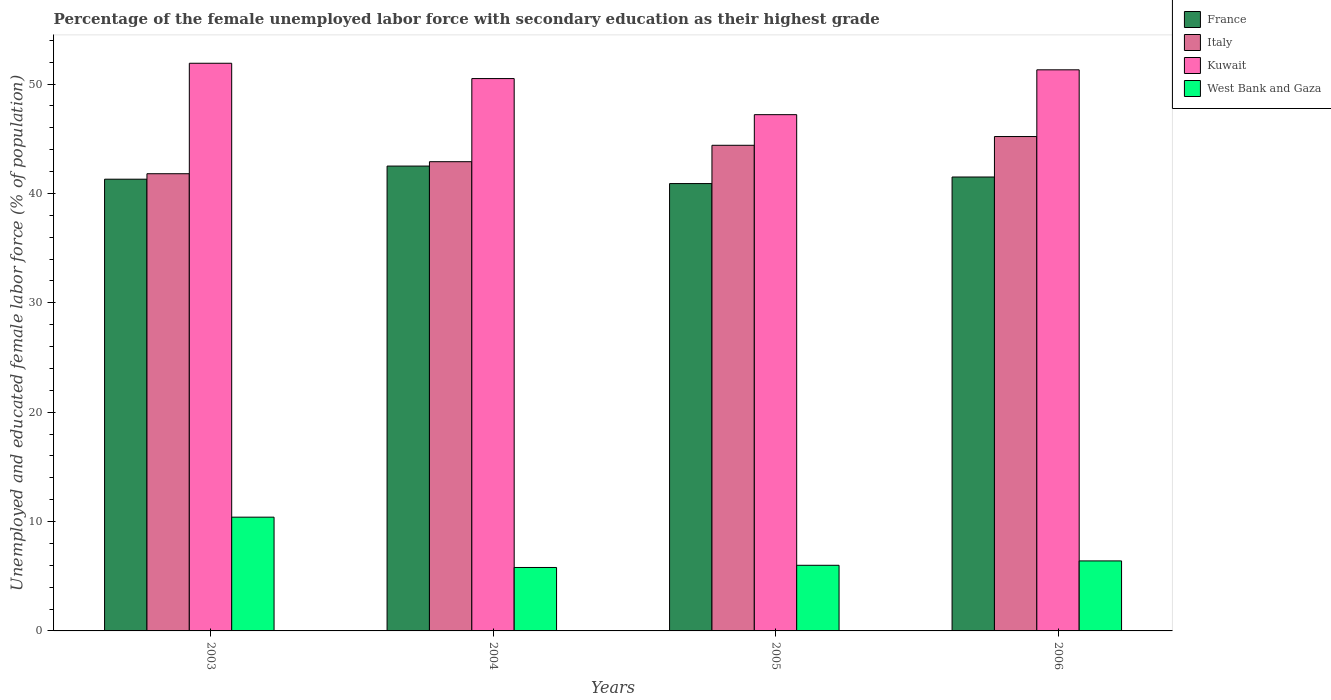Are the number of bars per tick equal to the number of legend labels?
Provide a short and direct response. Yes. Are the number of bars on each tick of the X-axis equal?
Provide a short and direct response. Yes. How many bars are there on the 2nd tick from the right?
Offer a terse response. 4. What is the label of the 3rd group of bars from the left?
Your response must be concise. 2005. In how many cases, is the number of bars for a given year not equal to the number of legend labels?
Keep it short and to the point. 0. What is the percentage of the unemployed female labor force with secondary education in Kuwait in 2004?
Your response must be concise. 50.5. Across all years, what is the maximum percentage of the unemployed female labor force with secondary education in West Bank and Gaza?
Your answer should be very brief. 10.4. Across all years, what is the minimum percentage of the unemployed female labor force with secondary education in Kuwait?
Give a very brief answer. 47.2. In which year was the percentage of the unemployed female labor force with secondary education in France minimum?
Keep it short and to the point. 2005. What is the total percentage of the unemployed female labor force with secondary education in Kuwait in the graph?
Your answer should be compact. 200.9. What is the difference between the percentage of the unemployed female labor force with secondary education in France in 2005 and that in 2006?
Give a very brief answer. -0.6. What is the difference between the percentage of the unemployed female labor force with secondary education in Kuwait in 2003 and the percentage of the unemployed female labor force with secondary education in France in 2006?
Your response must be concise. 10.4. What is the average percentage of the unemployed female labor force with secondary education in Kuwait per year?
Your response must be concise. 50.23. In the year 2003, what is the difference between the percentage of the unemployed female labor force with secondary education in France and percentage of the unemployed female labor force with secondary education in Italy?
Your response must be concise. -0.5. In how many years, is the percentage of the unemployed female labor force with secondary education in France greater than 38 %?
Keep it short and to the point. 4. What is the ratio of the percentage of the unemployed female labor force with secondary education in Kuwait in 2003 to that in 2006?
Offer a very short reply. 1.01. Is the difference between the percentage of the unemployed female labor force with secondary education in France in 2003 and 2006 greater than the difference between the percentage of the unemployed female labor force with secondary education in Italy in 2003 and 2006?
Make the answer very short. Yes. What is the difference between the highest and the second highest percentage of the unemployed female labor force with secondary education in Italy?
Offer a very short reply. 0.8. What is the difference between the highest and the lowest percentage of the unemployed female labor force with secondary education in Italy?
Ensure brevity in your answer.  3.4. In how many years, is the percentage of the unemployed female labor force with secondary education in Kuwait greater than the average percentage of the unemployed female labor force with secondary education in Kuwait taken over all years?
Make the answer very short. 3. What does the 1st bar from the right in 2005 represents?
Keep it short and to the point. West Bank and Gaza. Are all the bars in the graph horizontal?
Your answer should be compact. No. How many years are there in the graph?
Make the answer very short. 4. Are the values on the major ticks of Y-axis written in scientific E-notation?
Make the answer very short. No. Does the graph contain any zero values?
Your answer should be compact. No. How many legend labels are there?
Provide a succinct answer. 4. What is the title of the graph?
Provide a succinct answer. Percentage of the female unemployed labor force with secondary education as their highest grade. Does "Nepal" appear as one of the legend labels in the graph?
Your answer should be very brief. No. What is the label or title of the X-axis?
Provide a succinct answer. Years. What is the label or title of the Y-axis?
Provide a succinct answer. Unemployed and educated female labor force (% of population). What is the Unemployed and educated female labor force (% of population) of France in 2003?
Keep it short and to the point. 41.3. What is the Unemployed and educated female labor force (% of population) in Italy in 2003?
Make the answer very short. 41.8. What is the Unemployed and educated female labor force (% of population) in Kuwait in 2003?
Provide a short and direct response. 51.9. What is the Unemployed and educated female labor force (% of population) of West Bank and Gaza in 2003?
Give a very brief answer. 10.4. What is the Unemployed and educated female labor force (% of population) of France in 2004?
Your response must be concise. 42.5. What is the Unemployed and educated female labor force (% of population) of Italy in 2004?
Provide a succinct answer. 42.9. What is the Unemployed and educated female labor force (% of population) in Kuwait in 2004?
Keep it short and to the point. 50.5. What is the Unemployed and educated female labor force (% of population) in West Bank and Gaza in 2004?
Your answer should be compact. 5.8. What is the Unemployed and educated female labor force (% of population) of France in 2005?
Give a very brief answer. 40.9. What is the Unemployed and educated female labor force (% of population) in Italy in 2005?
Keep it short and to the point. 44.4. What is the Unemployed and educated female labor force (% of population) of Kuwait in 2005?
Keep it short and to the point. 47.2. What is the Unemployed and educated female labor force (% of population) in West Bank and Gaza in 2005?
Make the answer very short. 6. What is the Unemployed and educated female labor force (% of population) in France in 2006?
Keep it short and to the point. 41.5. What is the Unemployed and educated female labor force (% of population) in Italy in 2006?
Keep it short and to the point. 45.2. What is the Unemployed and educated female labor force (% of population) in Kuwait in 2006?
Provide a short and direct response. 51.3. What is the Unemployed and educated female labor force (% of population) in West Bank and Gaza in 2006?
Offer a very short reply. 6.4. Across all years, what is the maximum Unemployed and educated female labor force (% of population) of France?
Your response must be concise. 42.5. Across all years, what is the maximum Unemployed and educated female labor force (% of population) in Italy?
Your response must be concise. 45.2. Across all years, what is the maximum Unemployed and educated female labor force (% of population) of Kuwait?
Give a very brief answer. 51.9. Across all years, what is the maximum Unemployed and educated female labor force (% of population) of West Bank and Gaza?
Your answer should be compact. 10.4. Across all years, what is the minimum Unemployed and educated female labor force (% of population) of France?
Ensure brevity in your answer.  40.9. Across all years, what is the minimum Unemployed and educated female labor force (% of population) in Italy?
Give a very brief answer. 41.8. Across all years, what is the minimum Unemployed and educated female labor force (% of population) in Kuwait?
Your answer should be very brief. 47.2. Across all years, what is the minimum Unemployed and educated female labor force (% of population) in West Bank and Gaza?
Make the answer very short. 5.8. What is the total Unemployed and educated female labor force (% of population) in France in the graph?
Provide a short and direct response. 166.2. What is the total Unemployed and educated female labor force (% of population) of Italy in the graph?
Ensure brevity in your answer.  174.3. What is the total Unemployed and educated female labor force (% of population) of Kuwait in the graph?
Your answer should be compact. 200.9. What is the total Unemployed and educated female labor force (% of population) of West Bank and Gaza in the graph?
Keep it short and to the point. 28.6. What is the difference between the Unemployed and educated female labor force (% of population) in France in 2003 and that in 2004?
Make the answer very short. -1.2. What is the difference between the Unemployed and educated female labor force (% of population) in Italy in 2003 and that in 2004?
Your response must be concise. -1.1. What is the difference between the Unemployed and educated female labor force (% of population) in France in 2003 and that in 2005?
Provide a short and direct response. 0.4. What is the difference between the Unemployed and educated female labor force (% of population) of Italy in 2003 and that in 2005?
Make the answer very short. -2.6. What is the difference between the Unemployed and educated female labor force (% of population) in Kuwait in 2003 and that in 2005?
Provide a short and direct response. 4.7. What is the difference between the Unemployed and educated female labor force (% of population) of West Bank and Gaza in 2003 and that in 2005?
Offer a terse response. 4.4. What is the difference between the Unemployed and educated female labor force (% of population) in France in 2003 and that in 2006?
Ensure brevity in your answer.  -0.2. What is the difference between the Unemployed and educated female labor force (% of population) of Italy in 2003 and that in 2006?
Provide a succinct answer. -3.4. What is the difference between the Unemployed and educated female labor force (% of population) of Kuwait in 2003 and that in 2006?
Keep it short and to the point. 0.6. What is the difference between the Unemployed and educated female labor force (% of population) in Italy in 2004 and that in 2005?
Offer a terse response. -1.5. What is the difference between the Unemployed and educated female labor force (% of population) in West Bank and Gaza in 2004 and that in 2005?
Ensure brevity in your answer.  -0.2. What is the difference between the Unemployed and educated female labor force (% of population) of France in 2004 and that in 2006?
Your answer should be very brief. 1. What is the difference between the Unemployed and educated female labor force (% of population) of Italy in 2004 and that in 2006?
Your answer should be very brief. -2.3. What is the difference between the Unemployed and educated female labor force (% of population) of Kuwait in 2004 and that in 2006?
Give a very brief answer. -0.8. What is the difference between the Unemployed and educated female labor force (% of population) in France in 2005 and that in 2006?
Your response must be concise. -0.6. What is the difference between the Unemployed and educated female labor force (% of population) of France in 2003 and the Unemployed and educated female labor force (% of population) of Italy in 2004?
Provide a succinct answer. -1.6. What is the difference between the Unemployed and educated female labor force (% of population) in France in 2003 and the Unemployed and educated female labor force (% of population) in Kuwait in 2004?
Your answer should be compact. -9.2. What is the difference between the Unemployed and educated female labor force (% of population) of France in 2003 and the Unemployed and educated female labor force (% of population) of West Bank and Gaza in 2004?
Your answer should be very brief. 35.5. What is the difference between the Unemployed and educated female labor force (% of population) of Italy in 2003 and the Unemployed and educated female labor force (% of population) of Kuwait in 2004?
Provide a short and direct response. -8.7. What is the difference between the Unemployed and educated female labor force (% of population) of Kuwait in 2003 and the Unemployed and educated female labor force (% of population) of West Bank and Gaza in 2004?
Your answer should be compact. 46.1. What is the difference between the Unemployed and educated female labor force (% of population) in France in 2003 and the Unemployed and educated female labor force (% of population) in Italy in 2005?
Offer a terse response. -3.1. What is the difference between the Unemployed and educated female labor force (% of population) of France in 2003 and the Unemployed and educated female labor force (% of population) of Kuwait in 2005?
Make the answer very short. -5.9. What is the difference between the Unemployed and educated female labor force (% of population) of France in 2003 and the Unemployed and educated female labor force (% of population) of West Bank and Gaza in 2005?
Keep it short and to the point. 35.3. What is the difference between the Unemployed and educated female labor force (% of population) in Italy in 2003 and the Unemployed and educated female labor force (% of population) in West Bank and Gaza in 2005?
Your response must be concise. 35.8. What is the difference between the Unemployed and educated female labor force (% of population) in Kuwait in 2003 and the Unemployed and educated female labor force (% of population) in West Bank and Gaza in 2005?
Offer a terse response. 45.9. What is the difference between the Unemployed and educated female labor force (% of population) in France in 2003 and the Unemployed and educated female labor force (% of population) in Italy in 2006?
Provide a short and direct response. -3.9. What is the difference between the Unemployed and educated female labor force (% of population) of France in 2003 and the Unemployed and educated female labor force (% of population) of West Bank and Gaza in 2006?
Make the answer very short. 34.9. What is the difference between the Unemployed and educated female labor force (% of population) in Italy in 2003 and the Unemployed and educated female labor force (% of population) in Kuwait in 2006?
Offer a very short reply. -9.5. What is the difference between the Unemployed and educated female labor force (% of population) in Italy in 2003 and the Unemployed and educated female labor force (% of population) in West Bank and Gaza in 2006?
Make the answer very short. 35.4. What is the difference between the Unemployed and educated female labor force (% of population) in Kuwait in 2003 and the Unemployed and educated female labor force (% of population) in West Bank and Gaza in 2006?
Your answer should be very brief. 45.5. What is the difference between the Unemployed and educated female labor force (% of population) of France in 2004 and the Unemployed and educated female labor force (% of population) of Italy in 2005?
Offer a terse response. -1.9. What is the difference between the Unemployed and educated female labor force (% of population) of France in 2004 and the Unemployed and educated female labor force (% of population) of Kuwait in 2005?
Ensure brevity in your answer.  -4.7. What is the difference between the Unemployed and educated female labor force (% of population) of France in 2004 and the Unemployed and educated female labor force (% of population) of West Bank and Gaza in 2005?
Make the answer very short. 36.5. What is the difference between the Unemployed and educated female labor force (% of population) in Italy in 2004 and the Unemployed and educated female labor force (% of population) in West Bank and Gaza in 2005?
Keep it short and to the point. 36.9. What is the difference between the Unemployed and educated female labor force (% of population) in Kuwait in 2004 and the Unemployed and educated female labor force (% of population) in West Bank and Gaza in 2005?
Offer a terse response. 44.5. What is the difference between the Unemployed and educated female labor force (% of population) of France in 2004 and the Unemployed and educated female labor force (% of population) of Italy in 2006?
Provide a succinct answer. -2.7. What is the difference between the Unemployed and educated female labor force (% of population) in France in 2004 and the Unemployed and educated female labor force (% of population) in West Bank and Gaza in 2006?
Give a very brief answer. 36.1. What is the difference between the Unemployed and educated female labor force (% of population) in Italy in 2004 and the Unemployed and educated female labor force (% of population) in West Bank and Gaza in 2006?
Give a very brief answer. 36.5. What is the difference between the Unemployed and educated female labor force (% of population) in Kuwait in 2004 and the Unemployed and educated female labor force (% of population) in West Bank and Gaza in 2006?
Make the answer very short. 44.1. What is the difference between the Unemployed and educated female labor force (% of population) of France in 2005 and the Unemployed and educated female labor force (% of population) of Kuwait in 2006?
Offer a very short reply. -10.4. What is the difference between the Unemployed and educated female labor force (% of population) in France in 2005 and the Unemployed and educated female labor force (% of population) in West Bank and Gaza in 2006?
Make the answer very short. 34.5. What is the difference between the Unemployed and educated female labor force (% of population) of Italy in 2005 and the Unemployed and educated female labor force (% of population) of West Bank and Gaza in 2006?
Ensure brevity in your answer.  38. What is the difference between the Unemployed and educated female labor force (% of population) of Kuwait in 2005 and the Unemployed and educated female labor force (% of population) of West Bank and Gaza in 2006?
Your response must be concise. 40.8. What is the average Unemployed and educated female labor force (% of population) of France per year?
Your answer should be very brief. 41.55. What is the average Unemployed and educated female labor force (% of population) in Italy per year?
Provide a short and direct response. 43.58. What is the average Unemployed and educated female labor force (% of population) in Kuwait per year?
Provide a short and direct response. 50.23. What is the average Unemployed and educated female labor force (% of population) in West Bank and Gaza per year?
Your response must be concise. 7.15. In the year 2003, what is the difference between the Unemployed and educated female labor force (% of population) of France and Unemployed and educated female labor force (% of population) of West Bank and Gaza?
Your answer should be compact. 30.9. In the year 2003, what is the difference between the Unemployed and educated female labor force (% of population) in Italy and Unemployed and educated female labor force (% of population) in West Bank and Gaza?
Make the answer very short. 31.4. In the year 2003, what is the difference between the Unemployed and educated female labor force (% of population) in Kuwait and Unemployed and educated female labor force (% of population) in West Bank and Gaza?
Offer a terse response. 41.5. In the year 2004, what is the difference between the Unemployed and educated female labor force (% of population) of France and Unemployed and educated female labor force (% of population) of West Bank and Gaza?
Offer a very short reply. 36.7. In the year 2004, what is the difference between the Unemployed and educated female labor force (% of population) of Italy and Unemployed and educated female labor force (% of population) of West Bank and Gaza?
Give a very brief answer. 37.1. In the year 2004, what is the difference between the Unemployed and educated female labor force (% of population) in Kuwait and Unemployed and educated female labor force (% of population) in West Bank and Gaza?
Give a very brief answer. 44.7. In the year 2005, what is the difference between the Unemployed and educated female labor force (% of population) in France and Unemployed and educated female labor force (% of population) in West Bank and Gaza?
Offer a very short reply. 34.9. In the year 2005, what is the difference between the Unemployed and educated female labor force (% of population) of Italy and Unemployed and educated female labor force (% of population) of West Bank and Gaza?
Your response must be concise. 38.4. In the year 2005, what is the difference between the Unemployed and educated female labor force (% of population) in Kuwait and Unemployed and educated female labor force (% of population) in West Bank and Gaza?
Give a very brief answer. 41.2. In the year 2006, what is the difference between the Unemployed and educated female labor force (% of population) of France and Unemployed and educated female labor force (% of population) of Italy?
Offer a terse response. -3.7. In the year 2006, what is the difference between the Unemployed and educated female labor force (% of population) of France and Unemployed and educated female labor force (% of population) of West Bank and Gaza?
Provide a succinct answer. 35.1. In the year 2006, what is the difference between the Unemployed and educated female labor force (% of population) in Italy and Unemployed and educated female labor force (% of population) in West Bank and Gaza?
Provide a short and direct response. 38.8. In the year 2006, what is the difference between the Unemployed and educated female labor force (% of population) in Kuwait and Unemployed and educated female labor force (% of population) in West Bank and Gaza?
Your answer should be very brief. 44.9. What is the ratio of the Unemployed and educated female labor force (% of population) of France in 2003 to that in 2004?
Offer a terse response. 0.97. What is the ratio of the Unemployed and educated female labor force (% of population) in Italy in 2003 to that in 2004?
Offer a very short reply. 0.97. What is the ratio of the Unemployed and educated female labor force (% of population) in Kuwait in 2003 to that in 2004?
Your answer should be compact. 1.03. What is the ratio of the Unemployed and educated female labor force (% of population) in West Bank and Gaza in 2003 to that in 2004?
Make the answer very short. 1.79. What is the ratio of the Unemployed and educated female labor force (% of population) in France in 2003 to that in 2005?
Your response must be concise. 1.01. What is the ratio of the Unemployed and educated female labor force (% of population) of Italy in 2003 to that in 2005?
Offer a very short reply. 0.94. What is the ratio of the Unemployed and educated female labor force (% of population) of Kuwait in 2003 to that in 2005?
Your answer should be compact. 1.1. What is the ratio of the Unemployed and educated female labor force (% of population) of West Bank and Gaza in 2003 to that in 2005?
Offer a very short reply. 1.73. What is the ratio of the Unemployed and educated female labor force (% of population) of France in 2003 to that in 2006?
Make the answer very short. 1. What is the ratio of the Unemployed and educated female labor force (% of population) in Italy in 2003 to that in 2006?
Provide a succinct answer. 0.92. What is the ratio of the Unemployed and educated female labor force (% of population) of Kuwait in 2003 to that in 2006?
Your answer should be very brief. 1.01. What is the ratio of the Unemployed and educated female labor force (% of population) in West Bank and Gaza in 2003 to that in 2006?
Offer a terse response. 1.62. What is the ratio of the Unemployed and educated female labor force (% of population) in France in 2004 to that in 2005?
Provide a succinct answer. 1.04. What is the ratio of the Unemployed and educated female labor force (% of population) of Italy in 2004 to that in 2005?
Provide a short and direct response. 0.97. What is the ratio of the Unemployed and educated female labor force (% of population) in Kuwait in 2004 to that in 2005?
Offer a terse response. 1.07. What is the ratio of the Unemployed and educated female labor force (% of population) of West Bank and Gaza in 2004 to that in 2005?
Ensure brevity in your answer.  0.97. What is the ratio of the Unemployed and educated female labor force (% of population) in France in 2004 to that in 2006?
Give a very brief answer. 1.02. What is the ratio of the Unemployed and educated female labor force (% of population) of Italy in 2004 to that in 2006?
Ensure brevity in your answer.  0.95. What is the ratio of the Unemployed and educated female labor force (% of population) of Kuwait in 2004 to that in 2006?
Your response must be concise. 0.98. What is the ratio of the Unemployed and educated female labor force (% of population) in West Bank and Gaza in 2004 to that in 2006?
Ensure brevity in your answer.  0.91. What is the ratio of the Unemployed and educated female labor force (% of population) of France in 2005 to that in 2006?
Your answer should be very brief. 0.99. What is the ratio of the Unemployed and educated female labor force (% of population) in Italy in 2005 to that in 2006?
Your answer should be compact. 0.98. What is the ratio of the Unemployed and educated female labor force (% of population) in Kuwait in 2005 to that in 2006?
Offer a very short reply. 0.92. What is the difference between the highest and the second highest Unemployed and educated female labor force (% of population) in Kuwait?
Offer a very short reply. 0.6. What is the difference between the highest and the lowest Unemployed and educated female labor force (% of population) of Italy?
Offer a terse response. 3.4. What is the difference between the highest and the lowest Unemployed and educated female labor force (% of population) in Kuwait?
Your answer should be compact. 4.7. What is the difference between the highest and the lowest Unemployed and educated female labor force (% of population) of West Bank and Gaza?
Give a very brief answer. 4.6. 